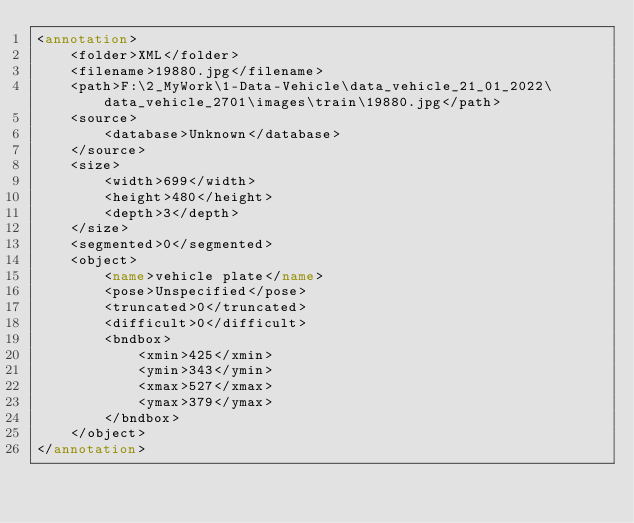Convert code to text. <code><loc_0><loc_0><loc_500><loc_500><_XML_><annotation>
	<folder>XML</folder>
	<filename>19880.jpg</filename>
	<path>F:\2_MyWork\1-Data-Vehicle\data_vehicle_21_01_2022\data_vehicle_2701\images\train\19880.jpg</path>
	<source>
		<database>Unknown</database>
	</source>
	<size>
		<width>699</width>
		<height>480</height>
		<depth>3</depth>
	</size>
	<segmented>0</segmented>
	<object>
		<name>vehicle plate</name>
		<pose>Unspecified</pose>
		<truncated>0</truncated>
		<difficult>0</difficult>
		<bndbox>
			<xmin>425</xmin>
			<ymin>343</ymin>
			<xmax>527</xmax>
			<ymax>379</ymax>
		</bndbox>
	</object>
</annotation>
</code> 